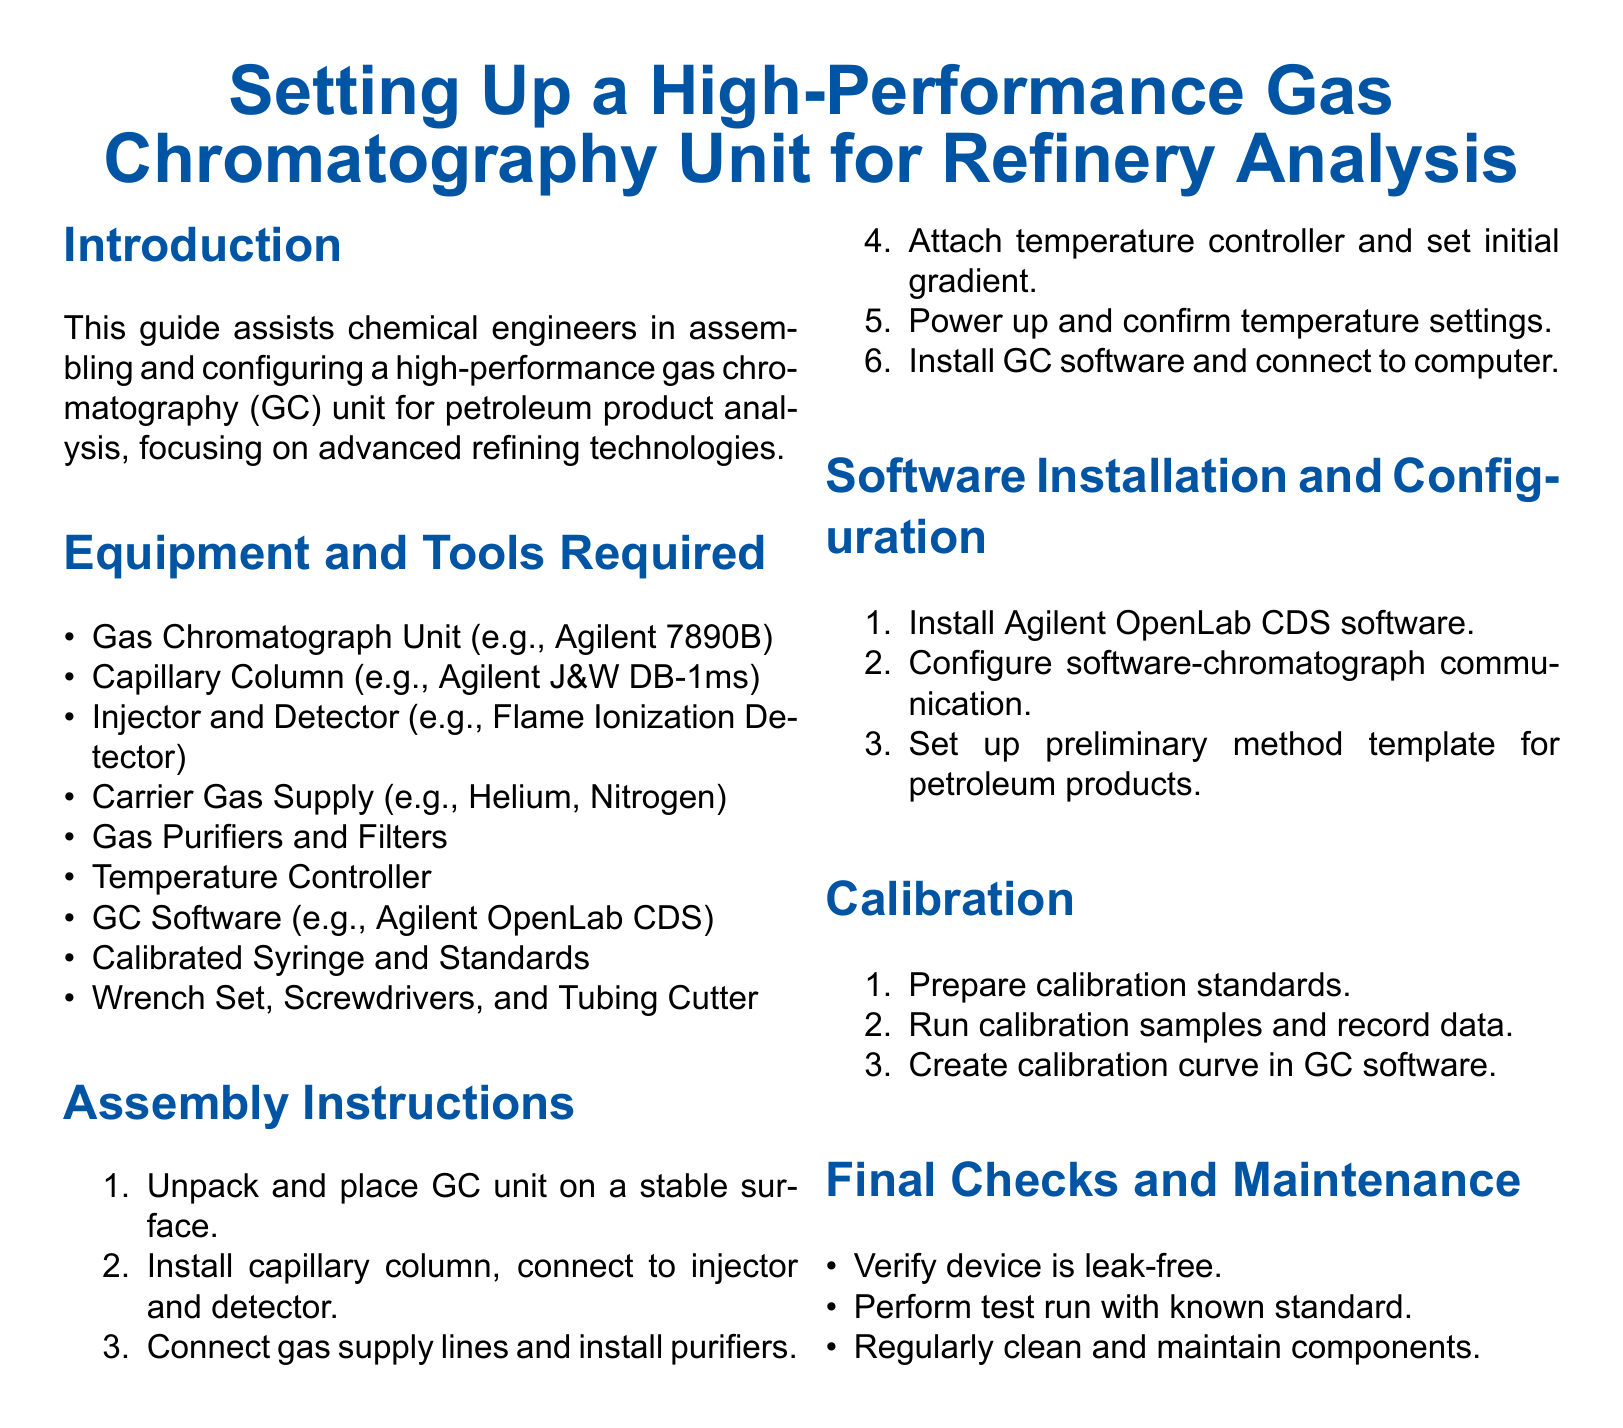What is the title of the document? The title summarizes the main subject of the document related to gas chromatography in refinery analysis.
Answer: Setting Up a High-Performance Gas Chromatography Unit for Refinery Analysis What is the first step in the assembly instructions? The first step outlines the initial action required to begin setting up the gas chromatograph unit.
Answer: Unpack and place GC unit on a stable surface Which software is mentioned for installation? The software specified is critical for operating the gas chromatography unit.
Answer: Agilent OpenLab CDS How many items are listed under "Equipment and Tools Required"? The count gives an overview of the necessary components for the setup process.
Answer: Nine What type of detector is mentioned in the equipment list? This determines the specific type of detector used in the gas chromatograph setup.
Answer: Flame Ionization Detector What is the last task mentioned in the calibration section? The final task summarizes what needs to be done to finalize the calibration process in the software.
Answer: Create calibration curve in GC software What should be verified as part of the final checks? This task ensures the safe operation of the gas chromatography unit.
Answer: Verify device is leak-free What is the purpose of the calibrated syringe in the setup? This specifies the function of one of the tools required for the operation of the gas chromatograph.
Answer: Prepare calibration standards 